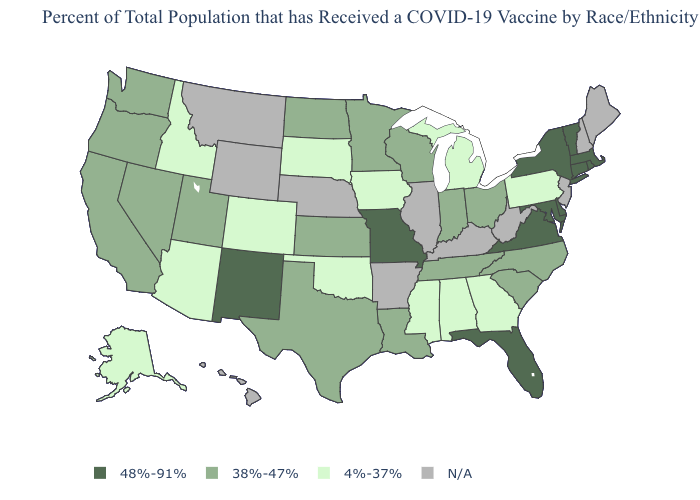Name the states that have a value in the range 48%-91%?
Concise answer only. Connecticut, Delaware, Florida, Maryland, Massachusetts, Missouri, New Mexico, New York, Rhode Island, Vermont, Virginia. Name the states that have a value in the range 48%-91%?
Write a very short answer. Connecticut, Delaware, Florida, Maryland, Massachusetts, Missouri, New Mexico, New York, Rhode Island, Vermont, Virginia. Among the states that border Maryland , which have the lowest value?
Write a very short answer. Pennsylvania. Among the states that border Nevada , which have the highest value?
Be succinct. California, Oregon, Utah. What is the value of Michigan?
Keep it brief. 4%-37%. What is the value of Oklahoma?
Keep it brief. 4%-37%. What is the lowest value in the MidWest?
Concise answer only. 4%-37%. Does the first symbol in the legend represent the smallest category?
Be succinct. No. Which states hav the highest value in the South?
Quick response, please. Delaware, Florida, Maryland, Virginia. How many symbols are there in the legend?
Short answer required. 4. What is the value of Minnesota?
Quick response, please. 38%-47%. Name the states that have a value in the range 38%-47%?
Be succinct. California, Indiana, Kansas, Louisiana, Minnesota, Nevada, North Carolina, North Dakota, Ohio, Oregon, South Carolina, Tennessee, Texas, Utah, Washington, Wisconsin. Does Alaska have the highest value in the West?
Short answer required. No. 